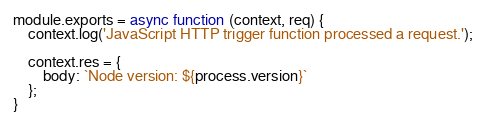Convert code to text. <code><loc_0><loc_0><loc_500><loc_500><_JavaScript_>module.exports = async function (context, req) {
    context.log('JavaScript HTTP trigger function processed a request.');

    context.res = {
        body: `Node version: ${process.version}`
    };
}</code> 